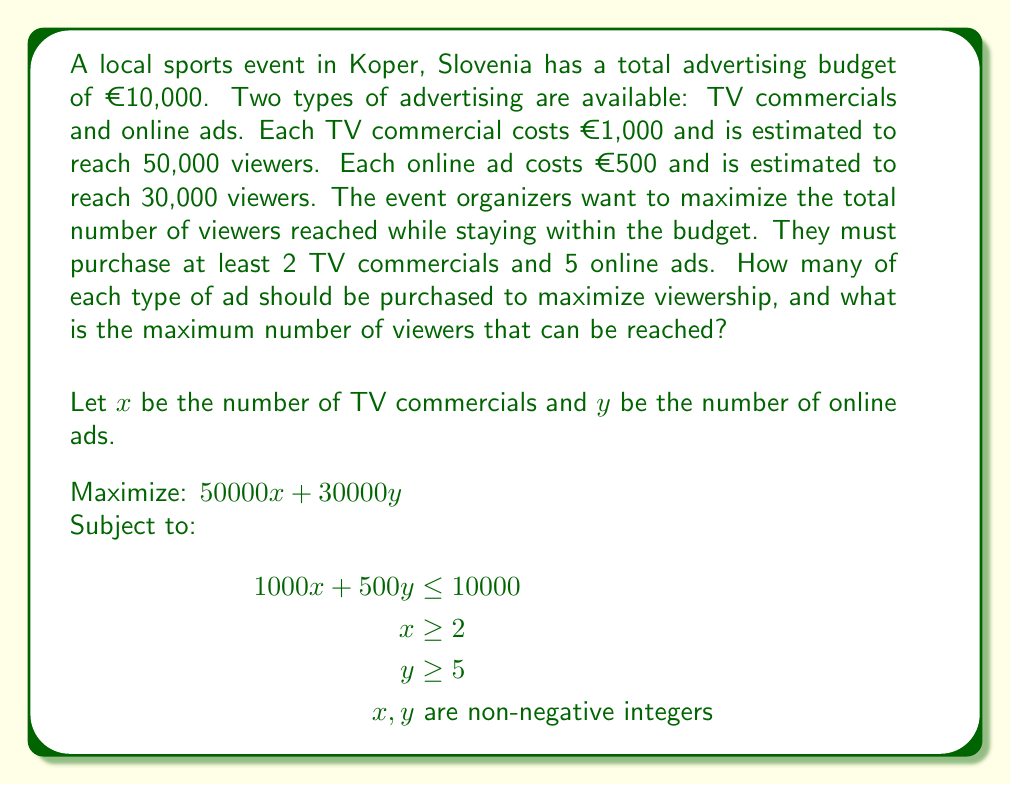Solve this math problem. To solve this linear programming problem, we'll use the following steps:

1. Set up the objective function and constraints:
   Maximize: $Z = 50000x + 30000y$
   Subject to:
   $1000x + 500y \leq 10000$ (budget constraint)
   $x \geq 2$
   $y \geq 5$
   $x, y$ are non-negative integers

2. Convert the inequality constraints to equations by introducing slack variables:
   $1000x + 500y + s_1 = 10000$
   $x - s_2 = 2$
   $y - s_3 = 5$
   Where $s_1, s_2, s_3 \geq 0$

3. Solve using the simplex method or graphical method. In this case, we'll use the graphical method due to its simplicity for a two-variable problem.

4. Plot the constraints:
   From the budget constraint: $y = 20 - 2x$
   $x \geq 2$
   $y \geq 5$

5. Find the feasible region:
   The feasible region is bounded by the lines $x = 2$, $y = 5$, and $y = 20 - 2x$.

6. Find the corner points of the feasible region:
   A: (2, 5)
   B: (2, 16)
   C: (7.5, 5)

7. Evaluate the objective function at each corner point:
   A: $Z(2, 5) = 50000(2) + 30000(5) = 250000$
   B: $Z(2, 16) = 50000(2) + 30000(16) = 580000$
   C: $Z(7.5, 5) = 50000(7.5) + 30000(5) = 525000$

8. The maximum value occurs at point B (2, 16).

9. Since we need integer solutions, we round down to (2, 16).

Therefore, the optimal solution is to purchase 2 TV commercials and 16 online ads.
Answer: The event organizers should purchase 2 TV commercials and 16 online ads to maximize viewership. The maximum number of viewers that can be reached is:

$50000(2) + 30000(16) = 100000 + 480000 = 580000$ viewers 